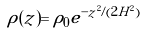<formula> <loc_0><loc_0><loc_500><loc_500>\rho ( z ) = \rho _ { 0 } e ^ { - z ^ { 2 } / ( 2 H ^ { 2 } ) }</formula> 